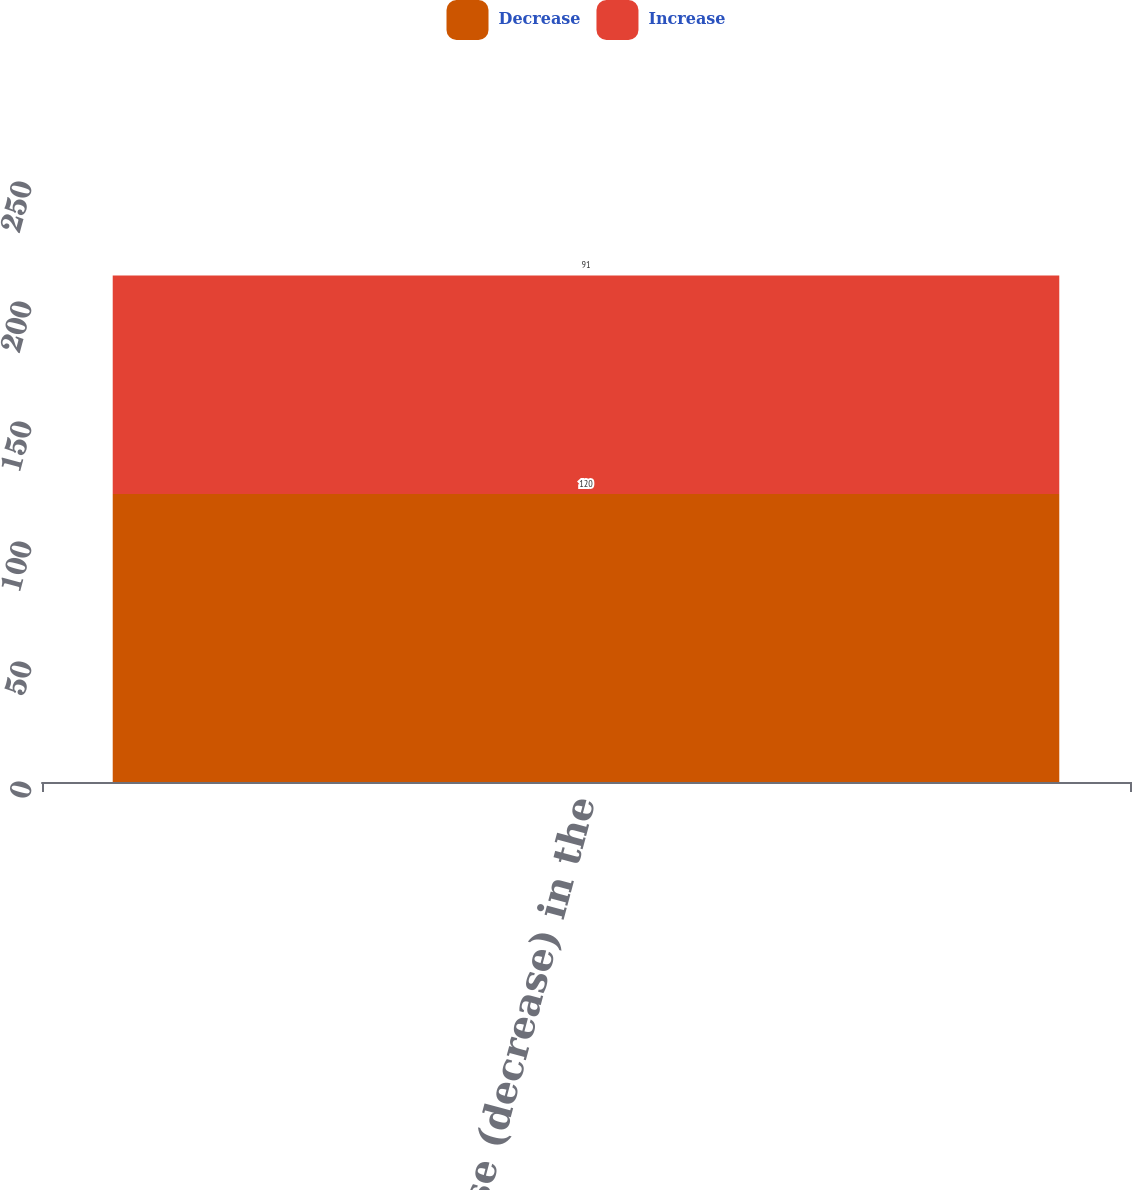<chart> <loc_0><loc_0><loc_500><loc_500><stacked_bar_chart><ecel><fcel>Increase (decrease) in the<nl><fcel>Decrease<fcel>120<nl><fcel>Increase<fcel>91<nl></chart> 